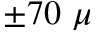Convert formula to latex. <formula><loc_0><loc_0><loc_500><loc_500>\pm 7 0 \mu</formula> 